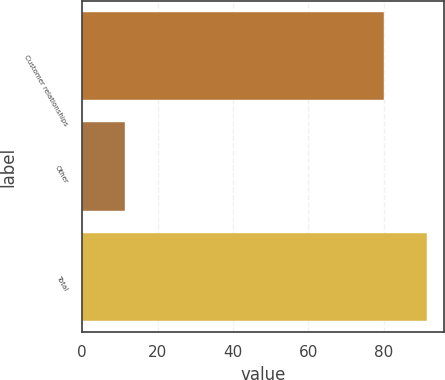Convert chart to OTSL. <chart><loc_0><loc_0><loc_500><loc_500><bar_chart><fcel>Customer relationships<fcel>Other<fcel>Total<nl><fcel>80<fcel>11.4<fcel>91.4<nl></chart> 